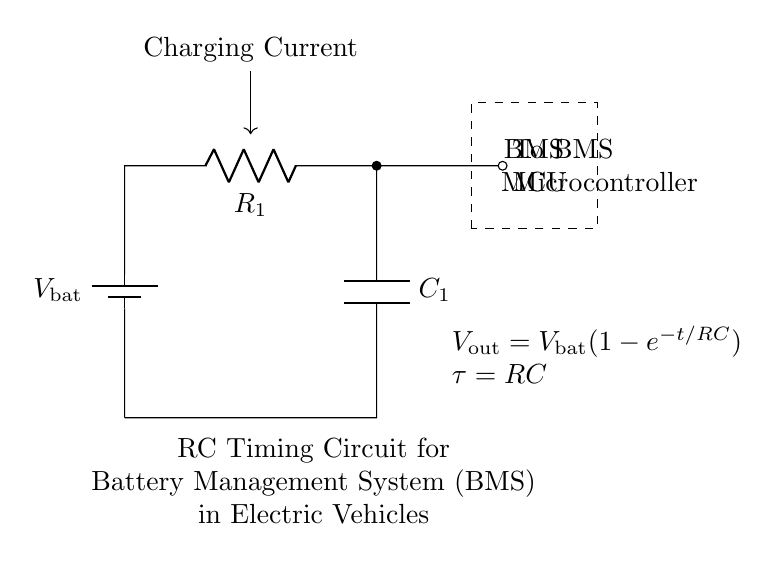What is the value of the capacitor in this circuit? The circuit diagram labels the capacitor as C_1, but it does not provide a specific numerical value. Therefore, we cannot ascertain the exact value from the diagram itself.
Answer: C_1 What is the output voltage formula of this RC circuit? The circuit diagram provides the formula for output voltage as V_out = V_bat(1-e^{-t/RC}). This formula describes how the voltage across the capacitor changes over time as it charges in an RC circuit.
Answer: V_out = V_bat(1-e^{-t/RC}) What does the term "tau" represent in this circuit? In the context of the given circuit, tau (τ) represents the time constant of the RC circuit, defined as τ = RC. This time constant determines how quickly the capacitor charges and is important for timing applications such as in a BMS.
Answer: τ = RC Which component is responsible for storing energy in this circuit? The component responsible for storing energy in this circuit is the capacitor (C_1), which accumulates electrical energy in the form of an electric field when voltage is applied across it.
Answer: C_1 What function does the resistor serve in this RC timer circuit? The resistor (R_1) in this RC timer circuit limits the charging current to the capacitor (C_1) during the charging process. It defines the rate at which the capacitor charges and ultimately influences the time constant (τ) of the circuit.
Answer: Limit charging current What is the primary purpose of this RC timing circuit in a BMS? The primary purpose of the RC timing circuit in a Battery Management System is to regulate the charging and discharging processes by controlling the timing of voltage changes to protect the battery from overcharging and deep discharging.
Answer: Regulate charging 